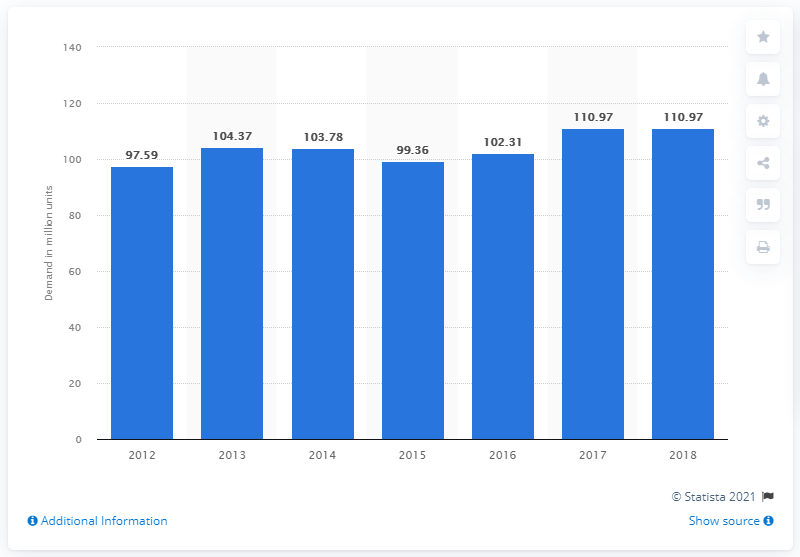Mention a couple of crucial points in this snapshot. According to a recent report, the global demand for air conditioners in 2018 was 110.97 million units. 